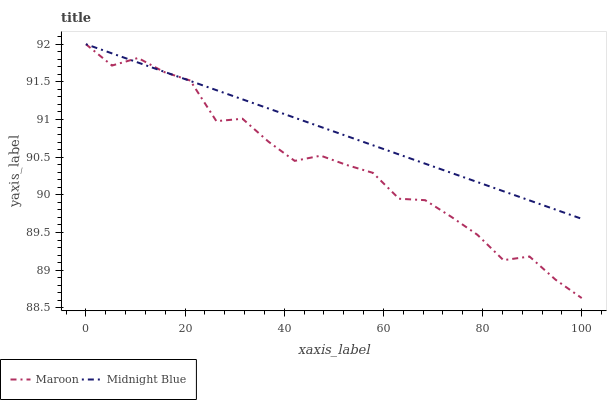Does Maroon have the minimum area under the curve?
Answer yes or no. Yes. Does Midnight Blue have the maximum area under the curve?
Answer yes or no. Yes. Does Maroon have the maximum area under the curve?
Answer yes or no. No. Is Midnight Blue the smoothest?
Answer yes or no. Yes. Is Maroon the roughest?
Answer yes or no. Yes. Is Maroon the smoothest?
Answer yes or no. No. Does Maroon have the lowest value?
Answer yes or no. Yes. Does Maroon have the highest value?
Answer yes or no. Yes. Does Midnight Blue intersect Maroon?
Answer yes or no. Yes. Is Midnight Blue less than Maroon?
Answer yes or no. No. Is Midnight Blue greater than Maroon?
Answer yes or no. No. 